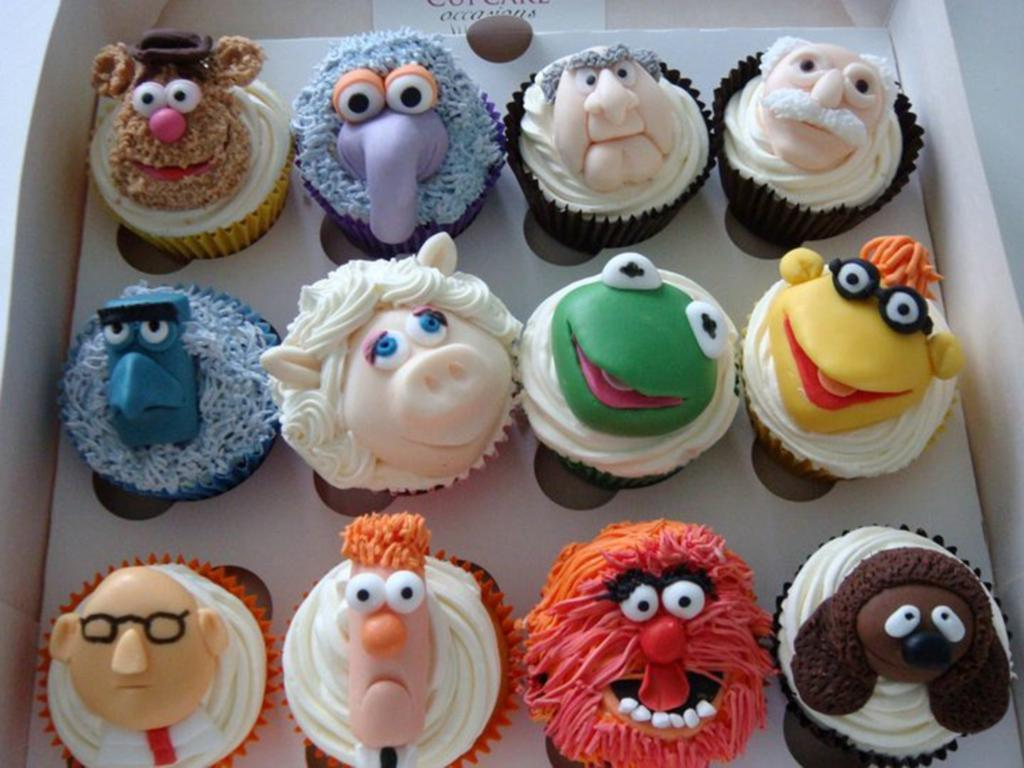What type of food can be seen in the image? There are muffins in the image. How are the muffins decorated? The muffins are decorated with cream shaped like cartoon faces. Where are the muffins stored? The muffins are kept in a box. What page of the book does the visitor turn to in the image? There is no book or visitor present in the image; it features muffins decorated with cream. 